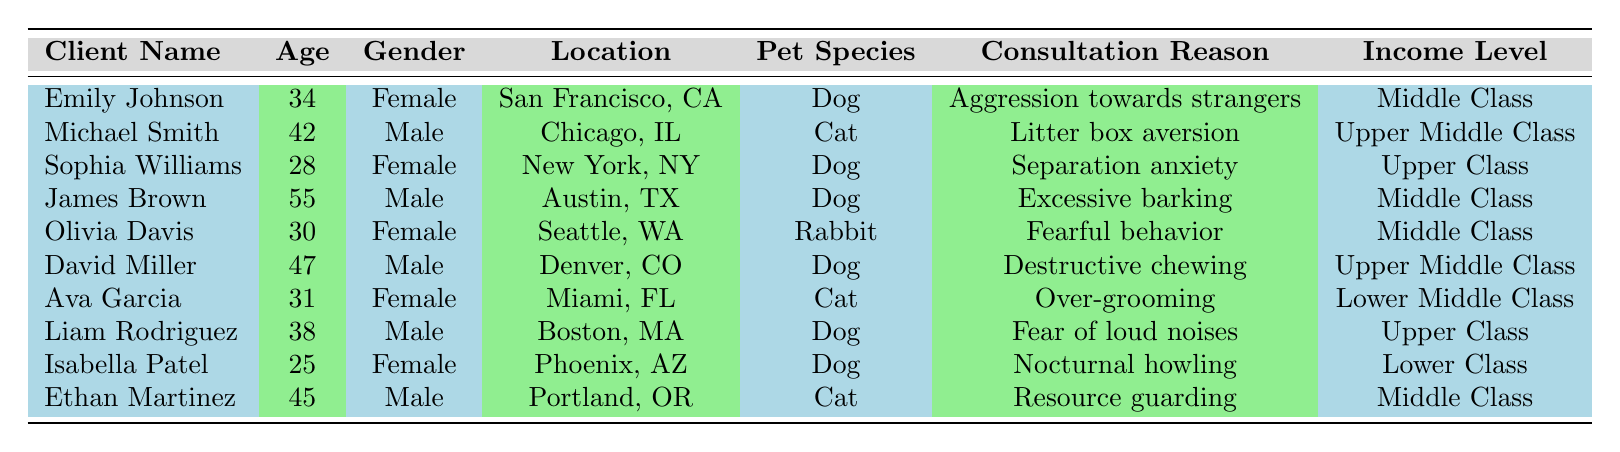What is the highest income level among the clients? By examining the income levels provided in the table, the highest income level mentioned is "Upper Class," which is represented by Sophia Williams and Liam Rodriguez.
Answer: Upper Class How many clients are male? There are five male clients: Michael Smith, James Brown, David Miller, Liam Rodriguez, and Ethan Martinez. Counting these gives a total of five.
Answer: 5 Which pet species is associated with the consultation reason "Over-grooming"? The client associated with the consultation reason "Over-grooming" is Ava Garcia, who has a Cat as her pet species.
Answer: Cat What is the average age of the clients? The ages of the clients are: 34, 42, 28, 55, 30, 47, 31, 38, 25, and 45. Summing these gives  34 + 42 + 28 + 55 + 30 + 47 + 31 + 38 + 25 + 45 =  405. There are 10 clients, so the average age is 405 / 10 = 40.5.
Answer: 40.5 Are there any clients with dogs from lower income levels? Inspecting the clients' information reveals that the only lower income level is "Lower Class," which is associated with Isabella Patel, who has a dog. Thus, the answer is yes.
Answer: Yes How many clients live in cities beginning with 'S'? Checking the locations, we find two clients: Emily Johnson in San Francisco, CA and Olivia Davis in Seattle, WA. Therefore, there are two clients living in cities starting with 'S'.
Answer: 2 Which client has the reason for consultation related to "Fearful behavior," and what is their pet species? The client with the reason "Fearful behavior" is Olivia Davis. When checking her entry, it's found that her pet species is a Rabbit.
Answer: Rabbit What is the difference in ages between the youngest and the oldest clients? The youngest client is Isabella Patel at age 25, and the oldest is James Brown at age 55. The difference in ages is 55 - 25 = 30.
Answer: 30 What percentage of clients have dogs as their pet species? Out of the 10 clients, 6 have dogs (Emily Johnson, Sophia Williams, James Brown, David Miller, Liam Rodriguez, Isabella Patel). Therefore, the percentage is (6/10) * 100 = 60%.
Answer: 60% Which location has clients who own both cats and dogs? Analyzing the table shows that the location with both cat and dog owners is Denver, CO (David Miller has a dog) and Portland, OR (Ethan Martinez has a cat). The locations of clients owning these pets do not overlap, so technically none share both species.
Answer: None 